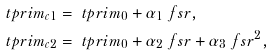<formula> <loc_0><loc_0><loc_500><loc_500>& \ t p r i m _ { c 1 } = \ t p r i m _ { 0 } + \alpha _ { 1 } \ f s r , \\ & \ t p r i m _ { c 2 } = \ t p r i m _ { 0 } + \alpha _ { 2 } \ f s r + \alpha _ { 3 } \ f s r ^ { 2 } ,</formula> 